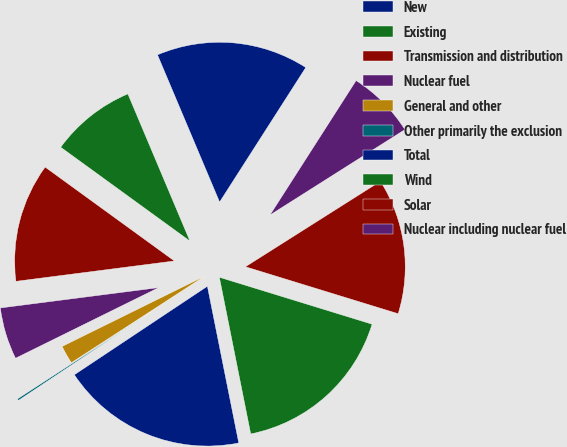Convert chart to OTSL. <chart><loc_0><loc_0><loc_500><loc_500><pie_chart><fcel>New<fcel>Existing<fcel>Transmission and distribution<fcel>Nuclear fuel<fcel>General and other<fcel>Other primarily the exclusion<fcel>Total<fcel>Wind<fcel>Solar<fcel>Nuclear including nuclear fuel<nl><fcel>15.42%<fcel>8.65%<fcel>12.03%<fcel>5.26%<fcel>1.87%<fcel>0.18%<fcel>18.8%<fcel>17.11%<fcel>13.73%<fcel>6.95%<nl></chart> 